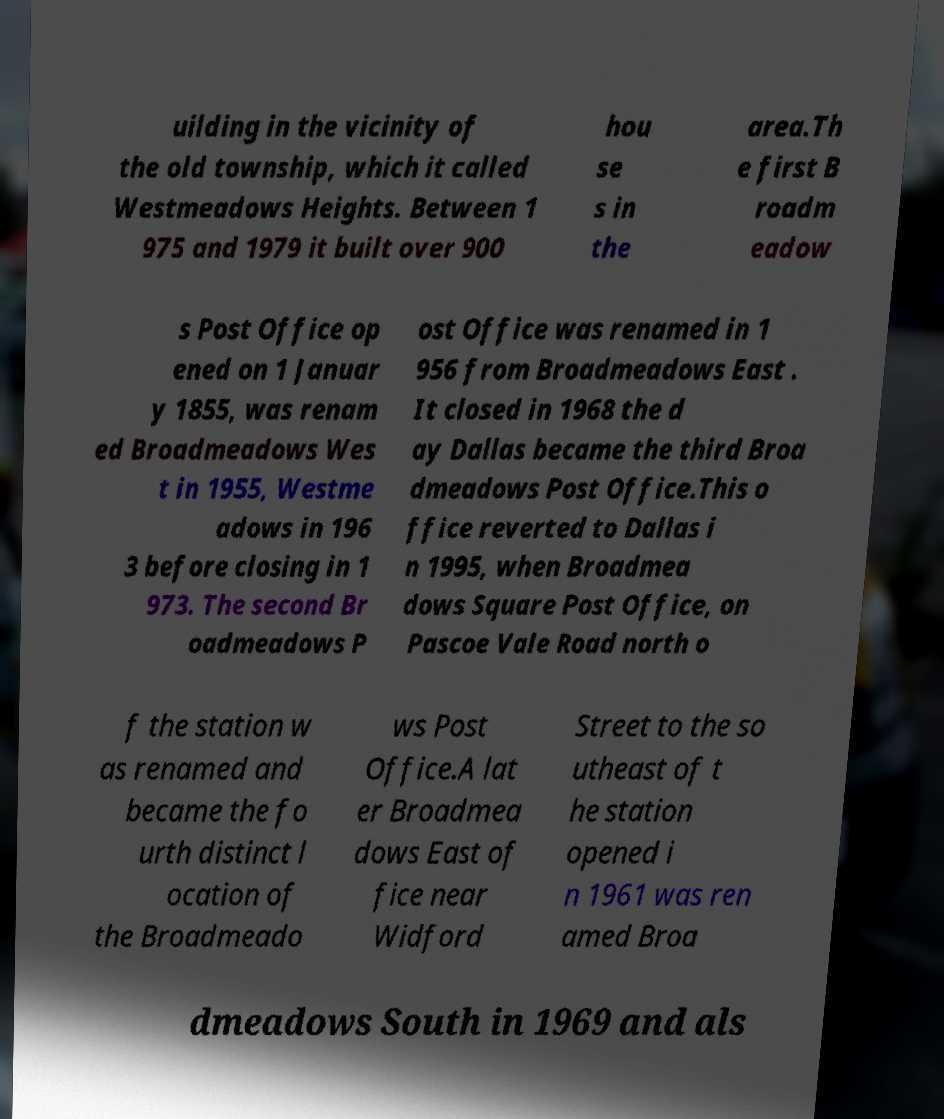Could you extract and type out the text from this image? uilding in the vicinity of the old township, which it called Westmeadows Heights. Between 1 975 and 1979 it built over 900 hou se s in the area.Th e first B roadm eadow s Post Office op ened on 1 Januar y 1855, was renam ed Broadmeadows Wes t in 1955, Westme adows in 196 3 before closing in 1 973. The second Br oadmeadows P ost Office was renamed in 1 956 from Broadmeadows East . It closed in 1968 the d ay Dallas became the third Broa dmeadows Post Office.This o ffice reverted to Dallas i n 1995, when Broadmea dows Square Post Office, on Pascoe Vale Road north o f the station w as renamed and became the fo urth distinct l ocation of the Broadmeado ws Post Office.A lat er Broadmea dows East of fice near Widford Street to the so utheast of t he station opened i n 1961 was ren amed Broa dmeadows South in 1969 and als 